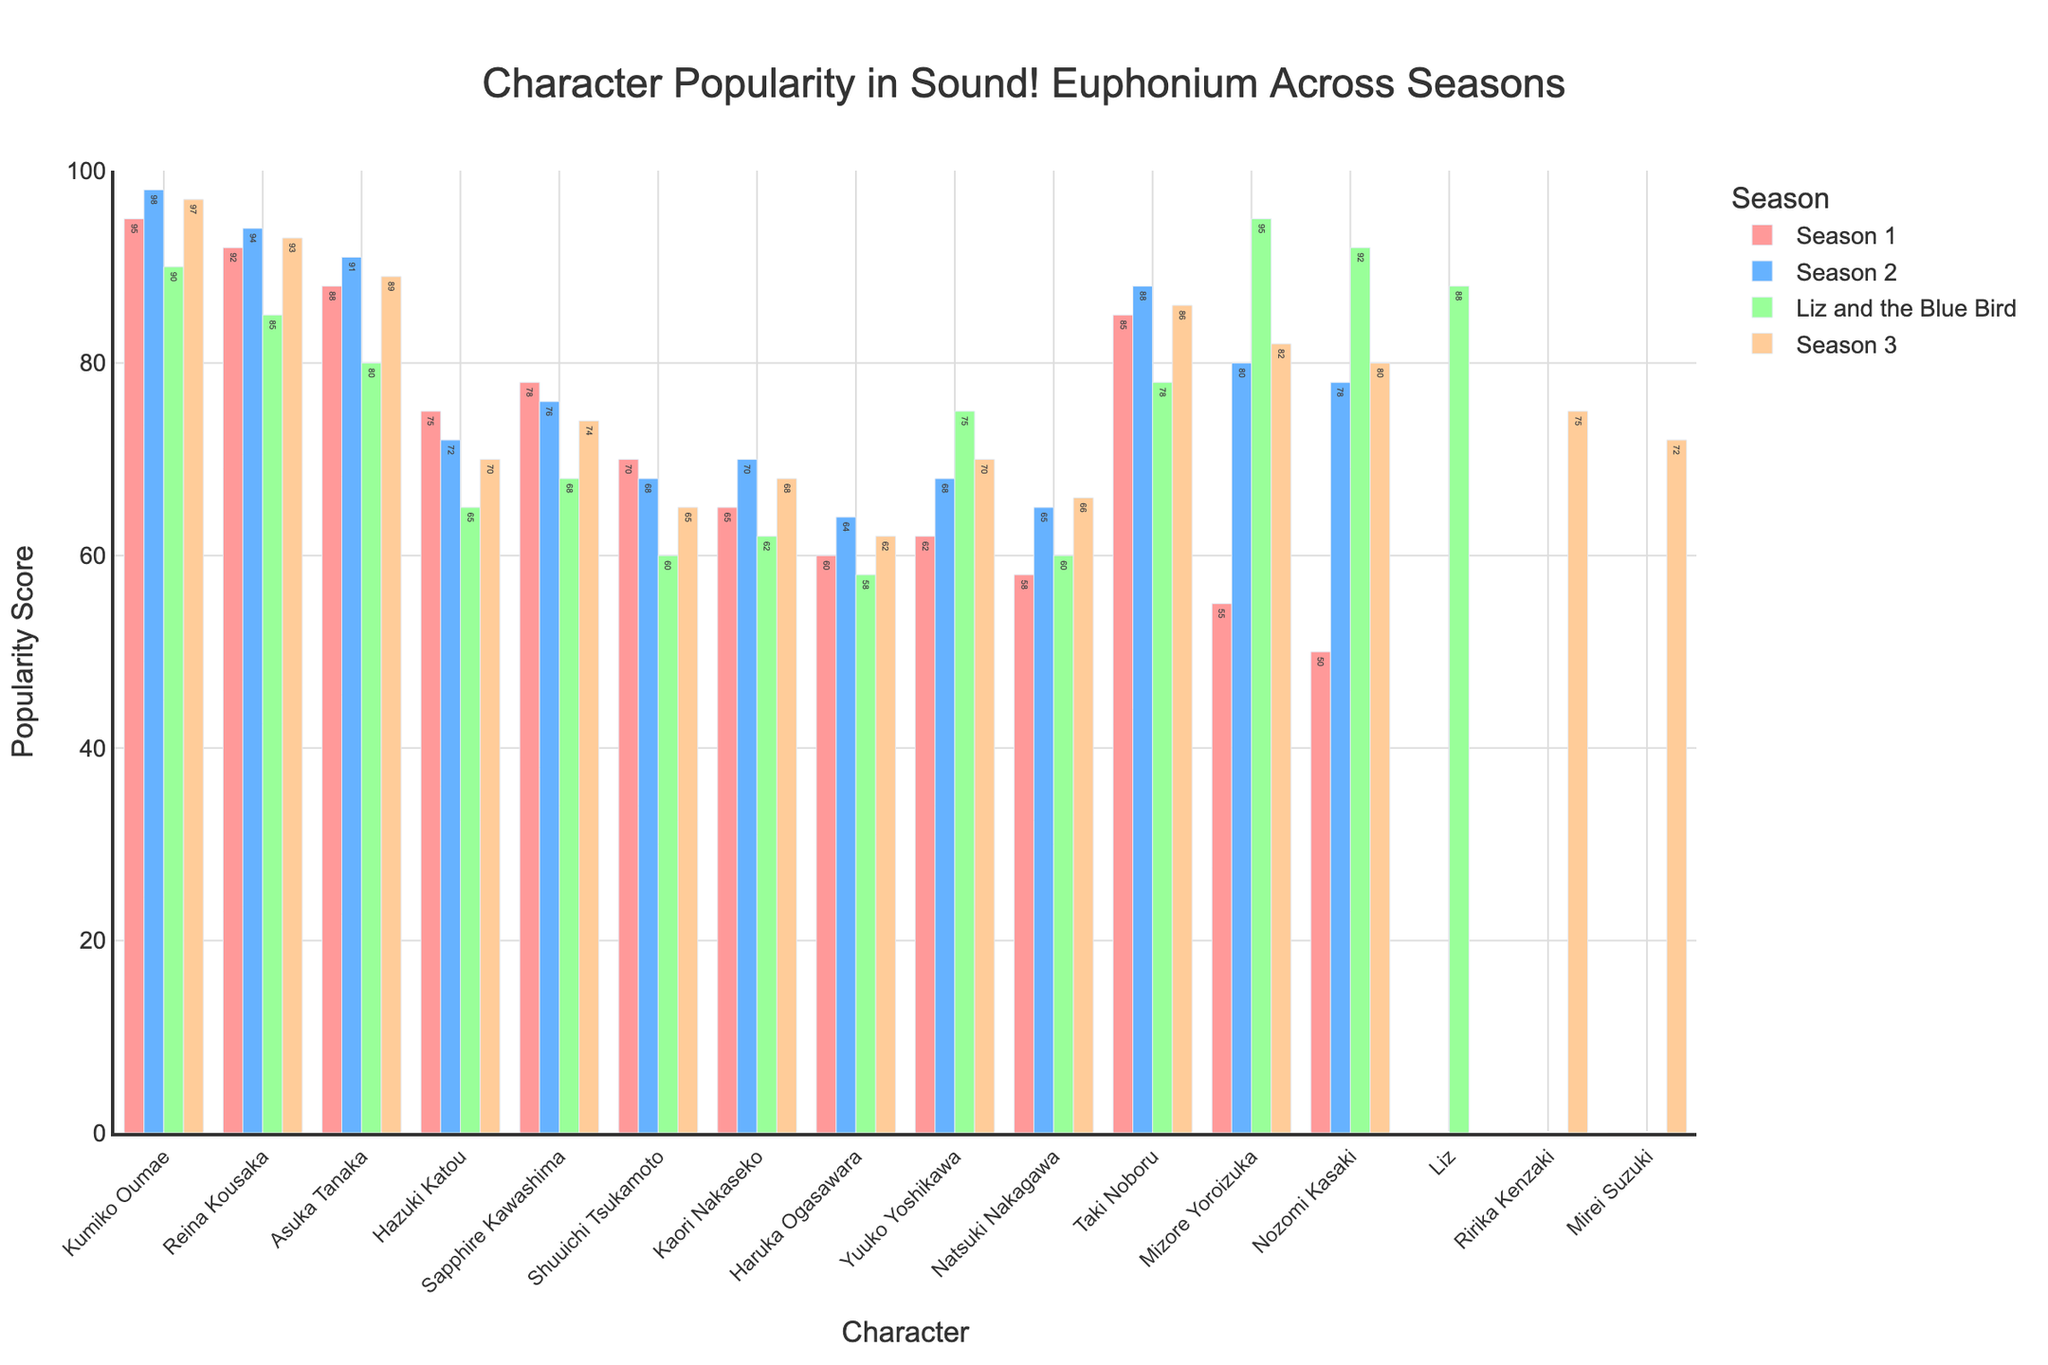Who is the most popular character in Season 1? Kumiko Oumae has the highest popularity score in Season 1, which is represented by the highest bar in that group.
Answer: Kumiko Oumae Which character showed the highest increase in popularity from Season 1 to Season 2? Mizore Yoroizuka shows the highest increase in popularity from Season 1 (55) to Season 2 (80). The difference is 25.
Answer: Mizore Yoroizuka What is the average popularity score of Kumiko Oumae across all seasons? The popularity scores of Kumiko Oumae are 95, 98, 90, and 97 across the four seasons. The average is (95+98+90+97)/4 = 95.
Answer: 95 Which characters had a lower popularity score in the "Liz and the Blue Bird" movie compared to Season 2? Comparing the Season 2 and "Liz and the Blue Bird" scores: Reina Kousaka (94 to 85), Asuka Tanaka (91 to 80), Shuuichi Tsukamoto (68 to 60), Kaori Nakaseko (70 to 62), and Haruka Ogasawara (64 to 58) had lower scores in the movie.
Answer: Reina Kousaka, Asuka Tanaka, Shuuichi Tsukamoto, Kaori Nakaseko, Haruka Ogasawara Which character's popularity improved consistently over all four seasons? Only Natsuki Nakagawa shows a consistent improvement in scores across all four seasons: 58, 65, 60, and 66.
Answer: Natsuki Nakagawa Between which two seasons did Mizore Yoroizuka see the biggest drop in popularity? Mizore Yoroizuka's scores are 55, 80, 95, and 82 across the seasons. The biggest drop is from "Liz and the Blue Bird" (95) to Season 3 (82), a difference of 13.
Answer: "Liz and the Blue Bird" to Season 3 Who has the highest popularity score in "Liz and the Blue Bird"? Liz, with a score of 88, has the highest popularity in "Liz and the Blue Bird".
Answer: Liz What is the combined popularity score of Kumiko Oumae and Reina Kousaka in Season 3? In Season 3, Kumiko Oumae has a score of 97 and Reina Kousaka has a score of 93. The combined score is 97 + 93 = 190.
Answer: 190 